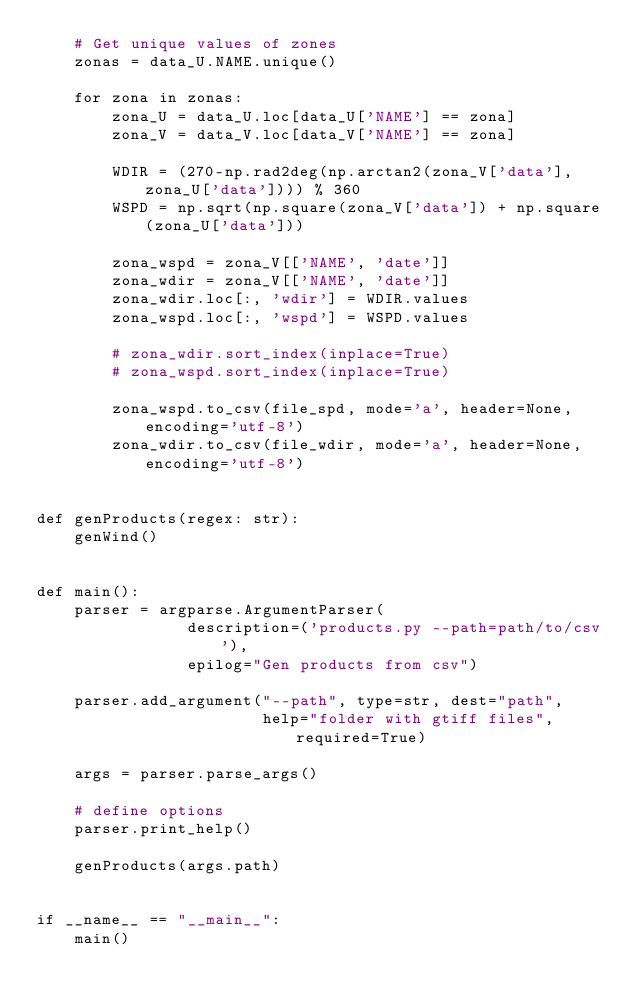Convert code to text. <code><loc_0><loc_0><loc_500><loc_500><_Python_>    # Get unique values of zones
    zonas = data_U.NAME.unique()

    for zona in zonas:
        zona_U = data_U.loc[data_U['NAME'] == zona]
        zona_V = data_V.loc[data_V['NAME'] == zona]

        WDIR = (270-np.rad2deg(np.arctan2(zona_V['data'], zona_U['data']))) % 360
        WSPD = np.sqrt(np.square(zona_V['data']) + np.square(zona_U['data']))

        zona_wspd = zona_V[['NAME', 'date']]
        zona_wdir = zona_V[['NAME', 'date']]
        zona_wdir.loc[:, 'wdir'] = WDIR.values
        zona_wspd.loc[:, 'wspd'] = WSPD.values

        # zona_wdir.sort_index(inplace=True)
        # zona_wspd.sort_index(inplace=True)

        zona_wspd.to_csv(file_spd, mode='a', header=None, encoding='utf-8')
        zona_wdir.to_csv(file_wdir, mode='a', header=None, encoding='utf-8')


def genProducts(regex: str):
    genWind()


def main():
    parser = argparse.ArgumentParser(
                description=('products.py --path=path/to/csv'),
                epilog="Gen products from csv")

    parser.add_argument("--path", type=str, dest="path",
                        help="folder with gtiff files", required=True)

    args = parser.parse_args()

    # define options
    parser.print_help()

    genProducts(args.path)


if __name__ == "__main__":
    main()
</code> 